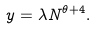<formula> <loc_0><loc_0><loc_500><loc_500>y = \lambda N ^ { \theta + 4 } .</formula> 